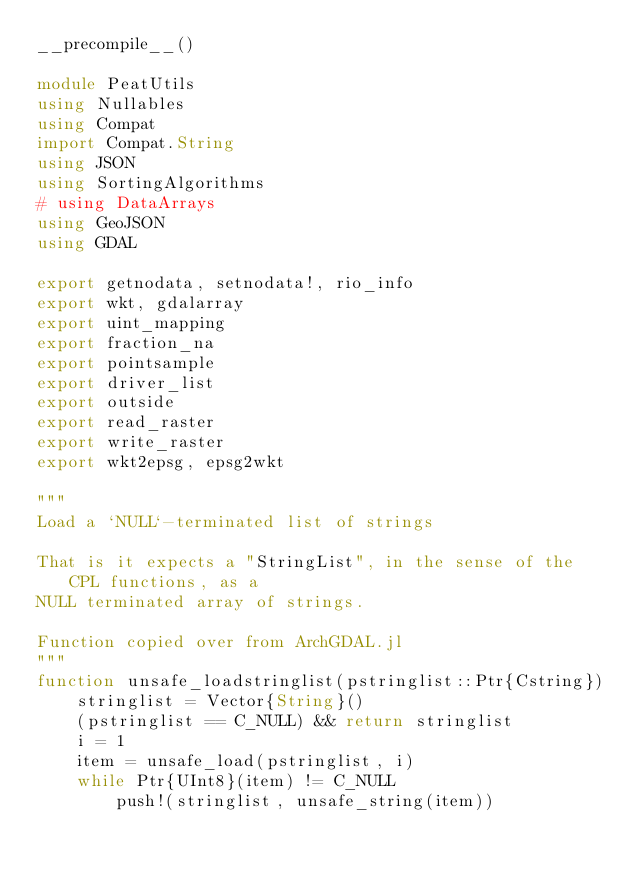Convert code to text. <code><loc_0><loc_0><loc_500><loc_500><_Julia_>__precompile__()

module PeatUtils
using Nullables
using Compat
import Compat.String
using JSON
using SortingAlgorithms
# using DataArrays
using GeoJSON
using GDAL

export getnodata, setnodata!, rio_info
export wkt, gdalarray
export uint_mapping
export fraction_na
export pointsample
export driver_list
export outside
export read_raster
export write_raster
export wkt2epsg, epsg2wkt

"""
Load a `NULL`-terminated list of strings

That is it expects a "StringList", in the sense of the CPL functions, as a
NULL terminated array of strings.

Function copied over from ArchGDAL.jl
"""
function unsafe_loadstringlist(pstringlist::Ptr{Cstring})
    stringlist = Vector{String}()
    (pstringlist == C_NULL) && return stringlist
    i = 1
    item = unsafe_load(pstringlist, i)
    while Ptr{UInt8}(item) != C_NULL
        push!(stringlist, unsafe_string(item))</code> 